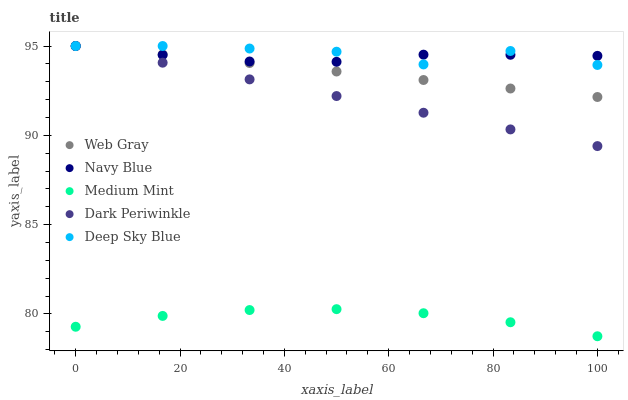Does Medium Mint have the minimum area under the curve?
Answer yes or no. Yes. Does Deep Sky Blue have the maximum area under the curve?
Answer yes or no. Yes. Does Navy Blue have the minimum area under the curve?
Answer yes or no. No. Does Navy Blue have the maximum area under the curve?
Answer yes or no. No. Is Dark Periwinkle the smoothest?
Answer yes or no. Yes. Is Deep Sky Blue the roughest?
Answer yes or no. Yes. Is Navy Blue the smoothest?
Answer yes or no. No. Is Navy Blue the roughest?
Answer yes or no. No. Does Medium Mint have the lowest value?
Answer yes or no. Yes. Does Web Gray have the lowest value?
Answer yes or no. No. Does Deep Sky Blue have the highest value?
Answer yes or no. Yes. Is Medium Mint less than Navy Blue?
Answer yes or no. Yes. Is Deep Sky Blue greater than Medium Mint?
Answer yes or no. Yes. Does Navy Blue intersect Dark Periwinkle?
Answer yes or no. Yes. Is Navy Blue less than Dark Periwinkle?
Answer yes or no. No. Is Navy Blue greater than Dark Periwinkle?
Answer yes or no. No. Does Medium Mint intersect Navy Blue?
Answer yes or no. No. 